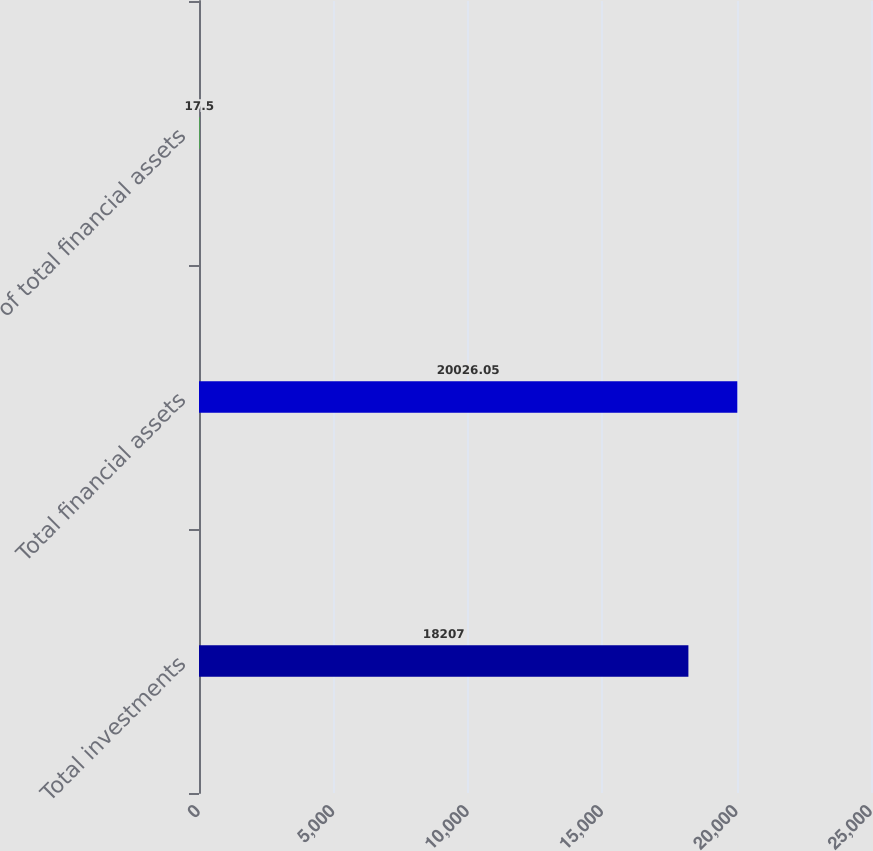Convert chart. <chart><loc_0><loc_0><loc_500><loc_500><bar_chart><fcel>Total investments<fcel>Total financial assets<fcel>of total financial assets<nl><fcel>18207<fcel>20026<fcel>17.5<nl></chart> 